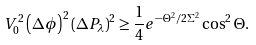Convert formula to latex. <formula><loc_0><loc_0><loc_500><loc_500>V _ { 0 } ^ { 2 } \left ( \Delta \phi \right ) ^ { 2 } \left ( \Delta P _ { \lambda } \right ) ^ { 2 } \geq \frac { 1 } { 4 } e ^ { - \Theta ^ { 2 } / 2 \Sigma ^ { 2 } } \cos ^ { 2 } \Theta .</formula> 